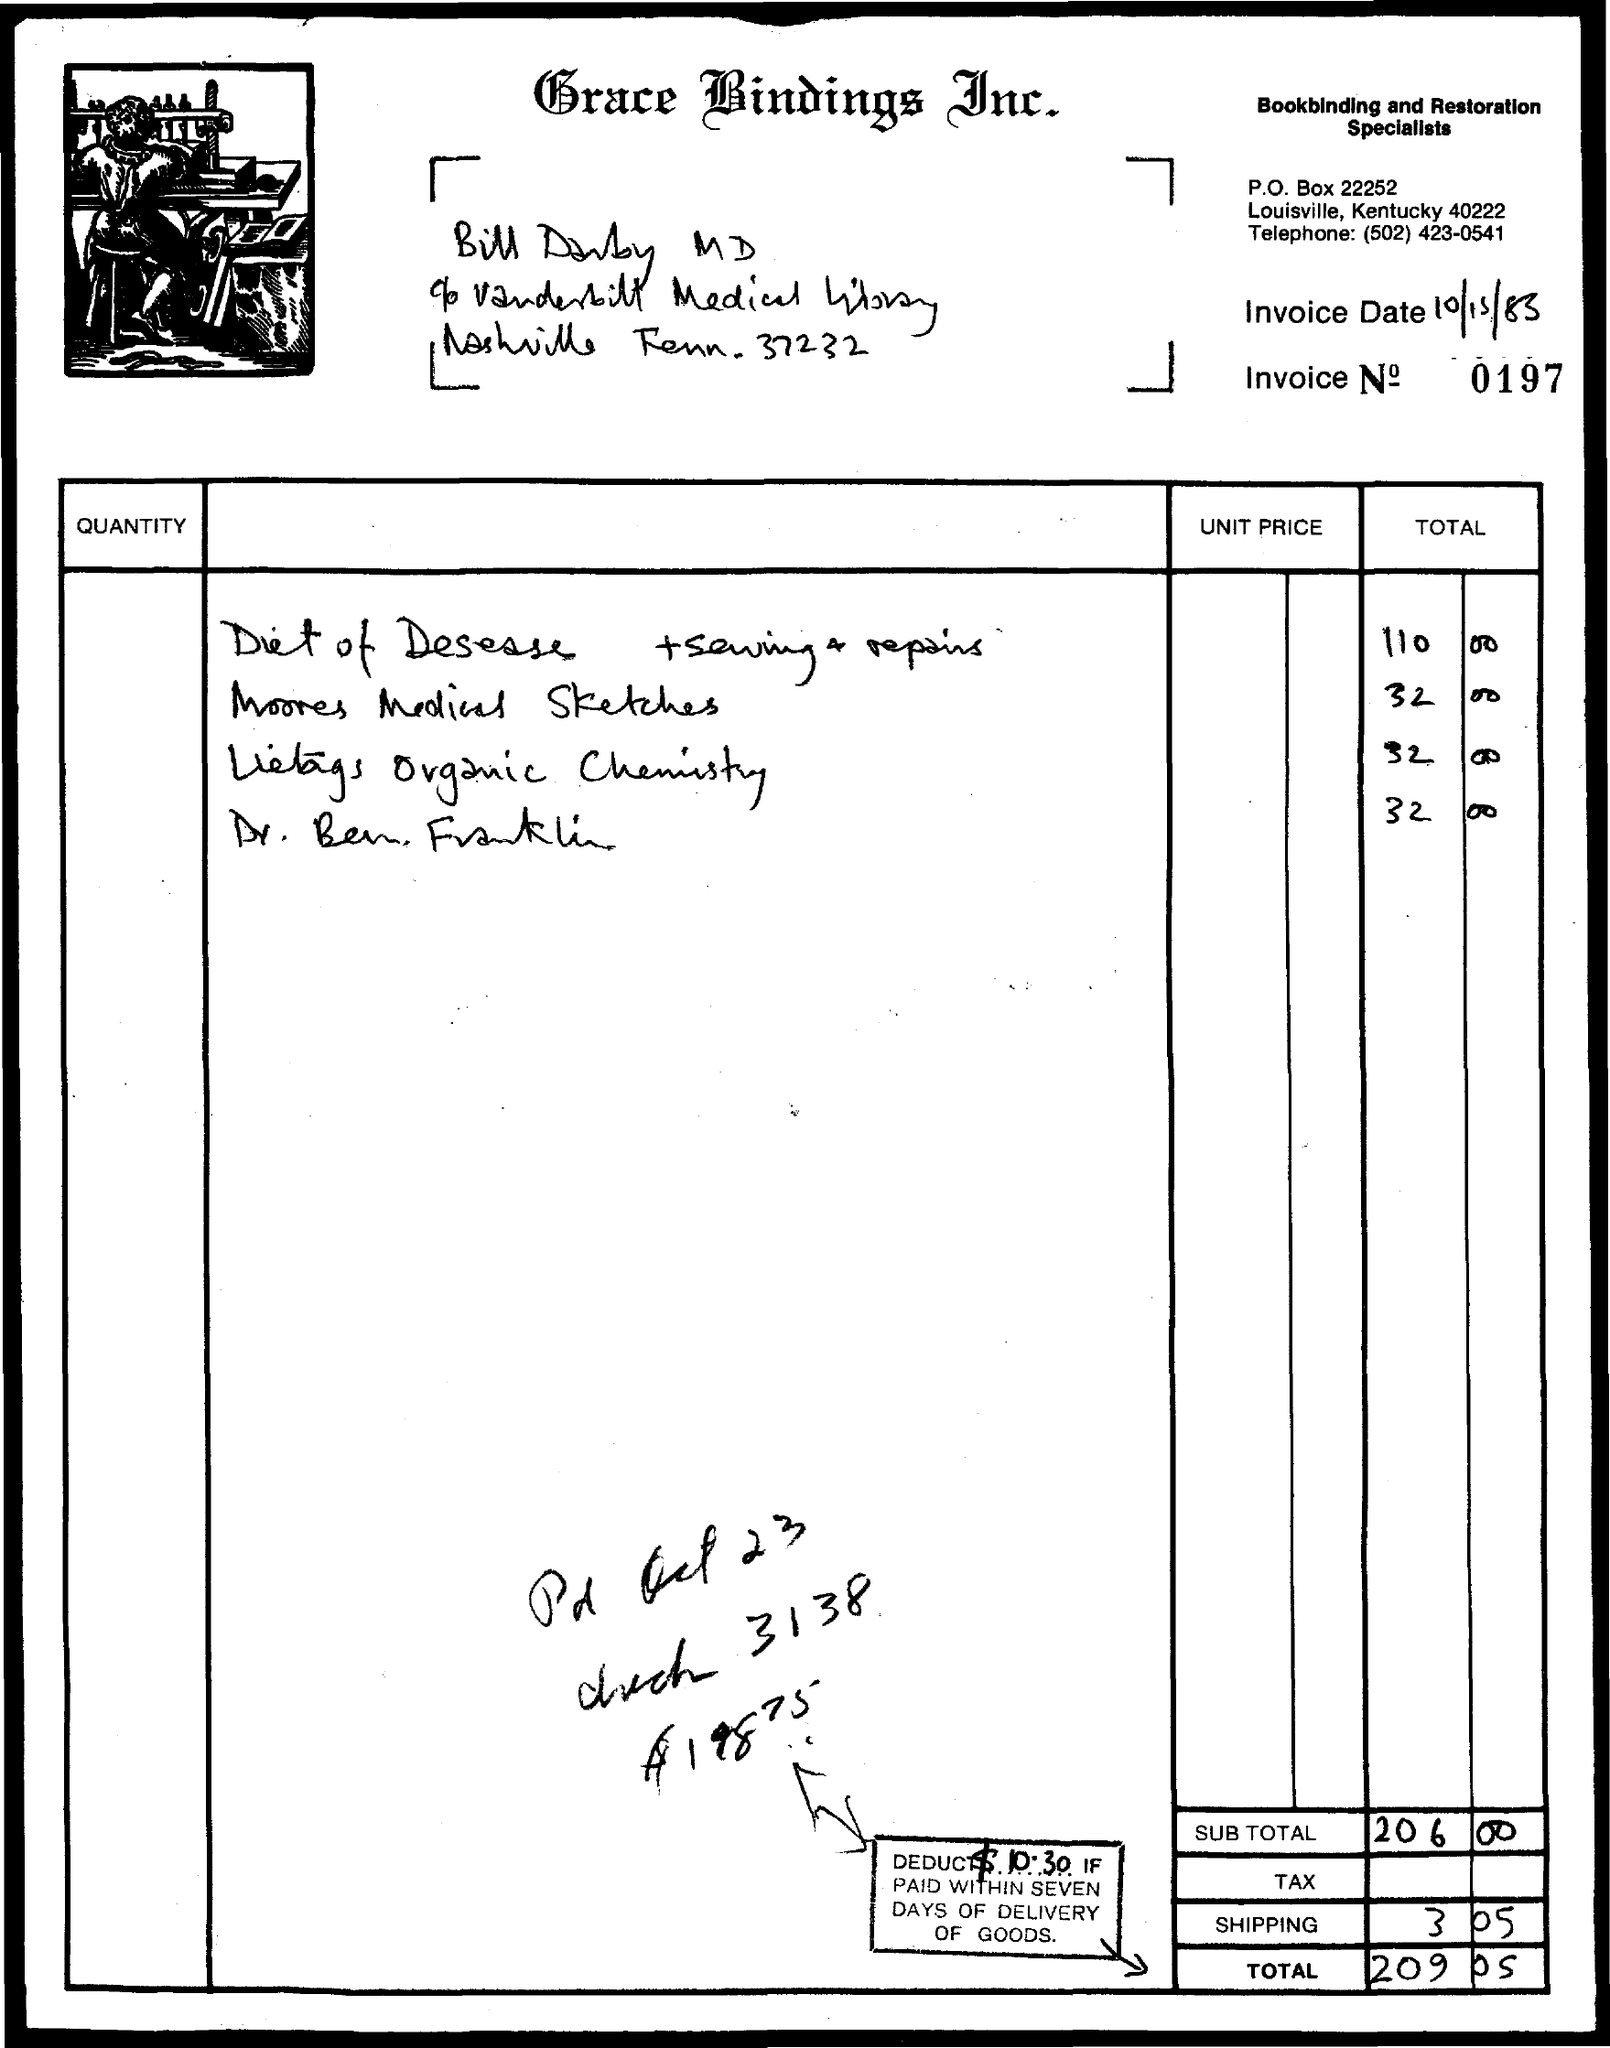Identify some key points in this picture. The invoice date is October 15, 1983. The subtotal is 206,000. The total is 209 and five cents. 